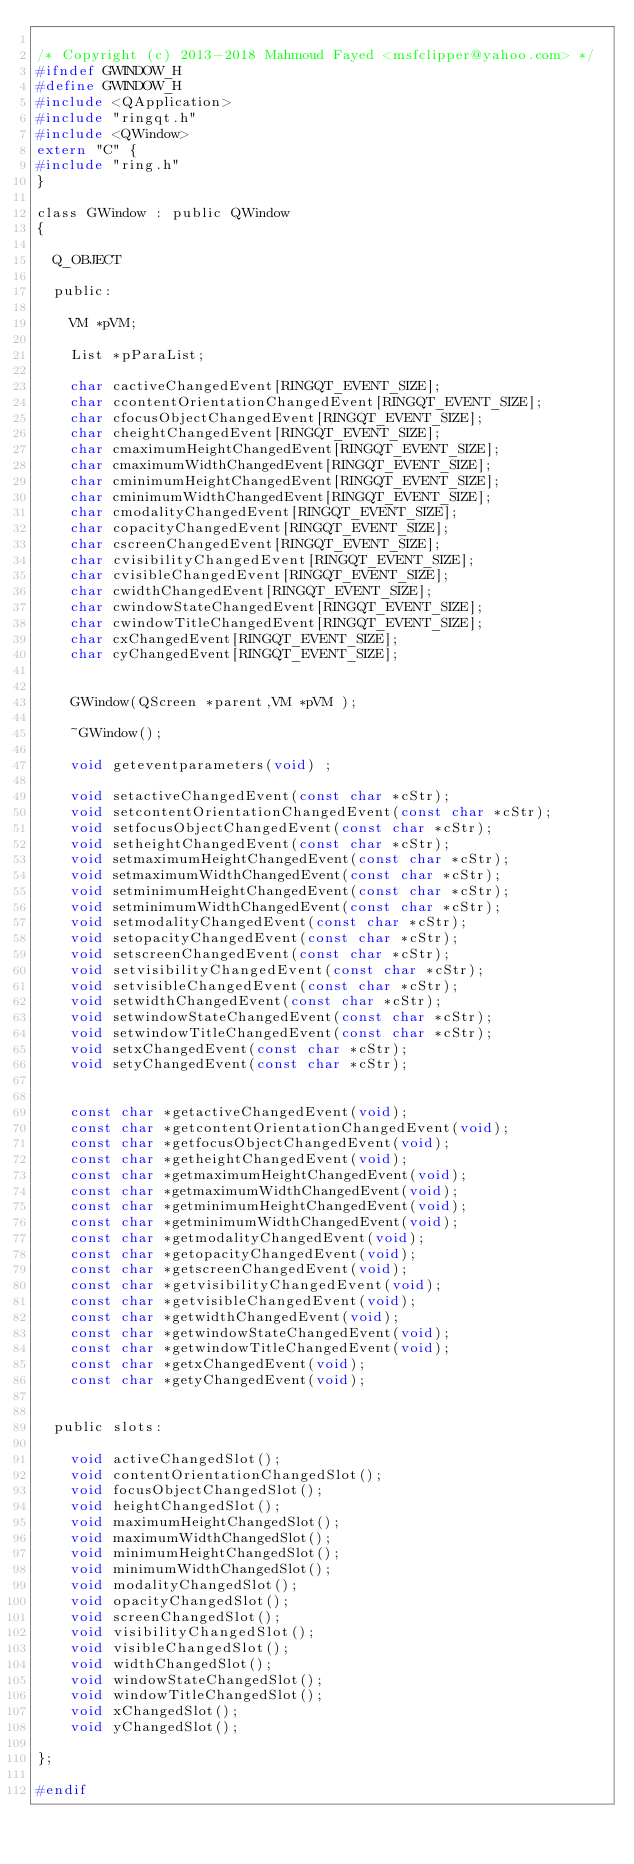Convert code to text. <code><loc_0><loc_0><loc_500><loc_500><_C_>
/* Copyright (c) 2013-2018 Mahmoud Fayed <msfclipper@yahoo.com> */
#ifndef GWINDOW_H
#define GWINDOW_H
#include <QApplication>
#include "ringqt.h"
#include <QWindow>
extern "C" {
#include "ring.h"
}

class GWindow : public QWindow
{

  Q_OBJECT

  public:

    VM *pVM;

    List *pParaList;

    char cactiveChangedEvent[RINGQT_EVENT_SIZE];
    char ccontentOrientationChangedEvent[RINGQT_EVENT_SIZE];
    char cfocusObjectChangedEvent[RINGQT_EVENT_SIZE];
    char cheightChangedEvent[RINGQT_EVENT_SIZE];
    char cmaximumHeightChangedEvent[RINGQT_EVENT_SIZE];
    char cmaximumWidthChangedEvent[RINGQT_EVENT_SIZE];
    char cminimumHeightChangedEvent[RINGQT_EVENT_SIZE];
    char cminimumWidthChangedEvent[RINGQT_EVENT_SIZE];
    char cmodalityChangedEvent[RINGQT_EVENT_SIZE];
    char copacityChangedEvent[RINGQT_EVENT_SIZE];
    char cscreenChangedEvent[RINGQT_EVENT_SIZE];
    char cvisibilityChangedEvent[RINGQT_EVENT_SIZE];
    char cvisibleChangedEvent[RINGQT_EVENT_SIZE];
    char cwidthChangedEvent[RINGQT_EVENT_SIZE];
    char cwindowStateChangedEvent[RINGQT_EVENT_SIZE];
    char cwindowTitleChangedEvent[RINGQT_EVENT_SIZE];
    char cxChangedEvent[RINGQT_EVENT_SIZE];
    char cyChangedEvent[RINGQT_EVENT_SIZE];


    GWindow(QScreen *parent,VM *pVM );

    ~GWindow();

    void geteventparameters(void) ;

    void setactiveChangedEvent(const char *cStr);
    void setcontentOrientationChangedEvent(const char *cStr);
    void setfocusObjectChangedEvent(const char *cStr);
    void setheightChangedEvent(const char *cStr);
    void setmaximumHeightChangedEvent(const char *cStr);
    void setmaximumWidthChangedEvent(const char *cStr);
    void setminimumHeightChangedEvent(const char *cStr);
    void setminimumWidthChangedEvent(const char *cStr);
    void setmodalityChangedEvent(const char *cStr);
    void setopacityChangedEvent(const char *cStr);
    void setscreenChangedEvent(const char *cStr);
    void setvisibilityChangedEvent(const char *cStr);
    void setvisibleChangedEvent(const char *cStr);
    void setwidthChangedEvent(const char *cStr);
    void setwindowStateChangedEvent(const char *cStr);
    void setwindowTitleChangedEvent(const char *cStr);
    void setxChangedEvent(const char *cStr);
    void setyChangedEvent(const char *cStr);


    const char *getactiveChangedEvent(void);
    const char *getcontentOrientationChangedEvent(void);
    const char *getfocusObjectChangedEvent(void);
    const char *getheightChangedEvent(void);
    const char *getmaximumHeightChangedEvent(void);
    const char *getmaximumWidthChangedEvent(void);
    const char *getminimumHeightChangedEvent(void);
    const char *getminimumWidthChangedEvent(void);
    const char *getmodalityChangedEvent(void);
    const char *getopacityChangedEvent(void);
    const char *getscreenChangedEvent(void);
    const char *getvisibilityChangedEvent(void);
    const char *getvisibleChangedEvent(void);
    const char *getwidthChangedEvent(void);
    const char *getwindowStateChangedEvent(void);
    const char *getwindowTitleChangedEvent(void);
    const char *getxChangedEvent(void);
    const char *getyChangedEvent(void);


  public slots:

    void activeChangedSlot();
    void contentOrientationChangedSlot();
    void focusObjectChangedSlot();
    void heightChangedSlot();
    void maximumHeightChangedSlot();
    void maximumWidthChangedSlot();
    void minimumHeightChangedSlot();
    void minimumWidthChangedSlot();
    void modalityChangedSlot();
    void opacityChangedSlot();
    void screenChangedSlot();
    void visibilityChangedSlot();
    void visibleChangedSlot();
    void widthChangedSlot();
    void windowStateChangedSlot();
    void windowTitleChangedSlot();
    void xChangedSlot();
    void yChangedSlot();

};

#endif

</code> 